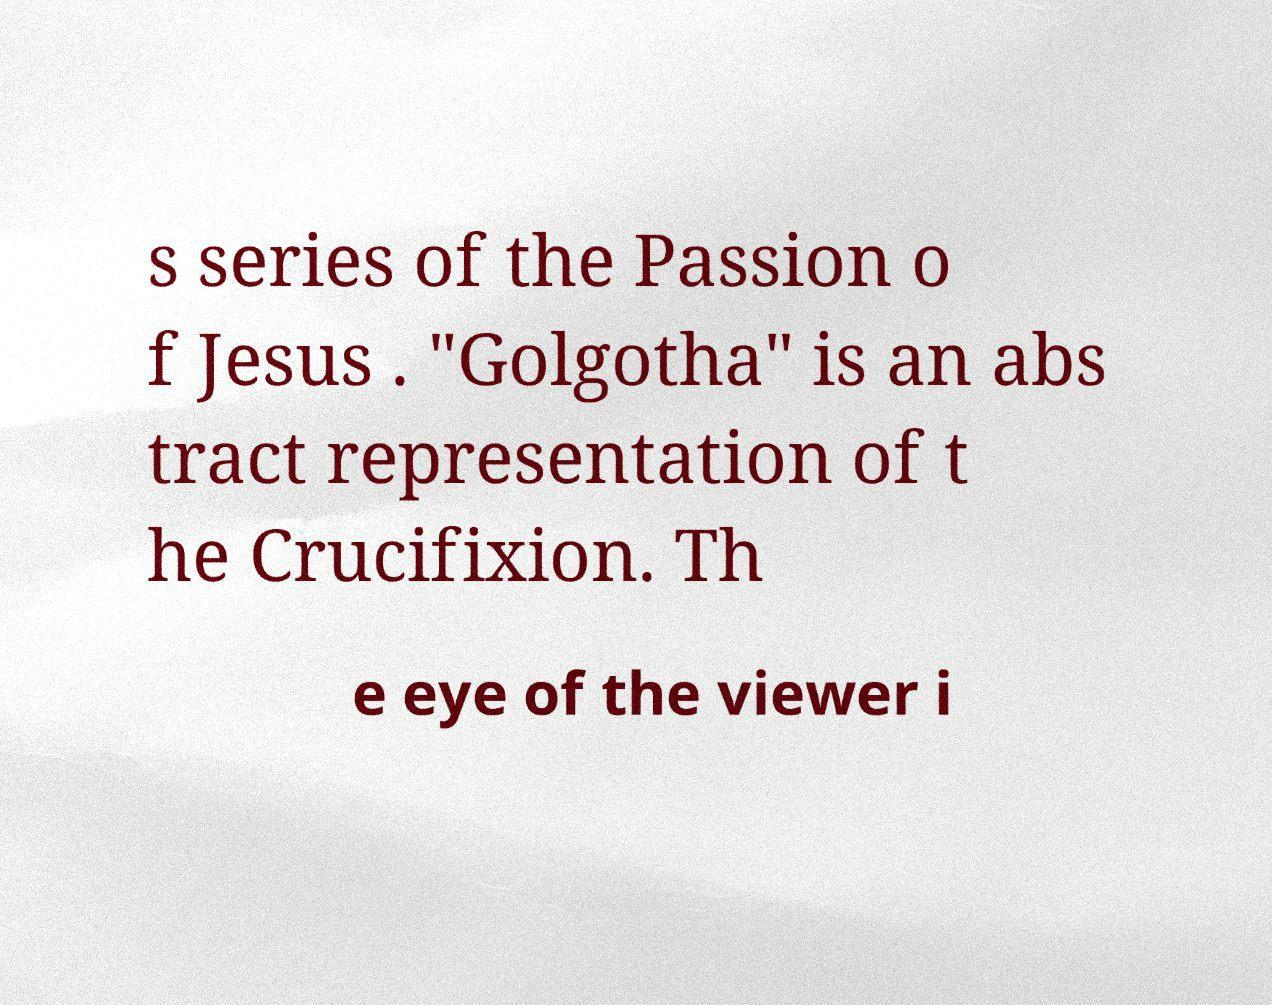Can you read and provide the text displayed in the image?This photo seems to have some interesting text. Can you extract and type it out for me? s series of the Passion o f Jesus . "Golgotha" is an abs tract representation of t he Crucifixion. Th e eye of the viewer i 